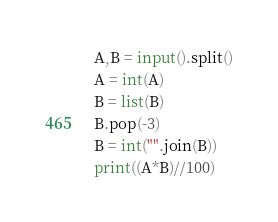Convert code to text. <code><loc_0><loc_0><loc_500><loc_500><_Python_>A,B = input().split()
A = int(A)
B = list(B)
B.pop(-3)
B = int("".join(B))
print((A*B)//100)</code> 